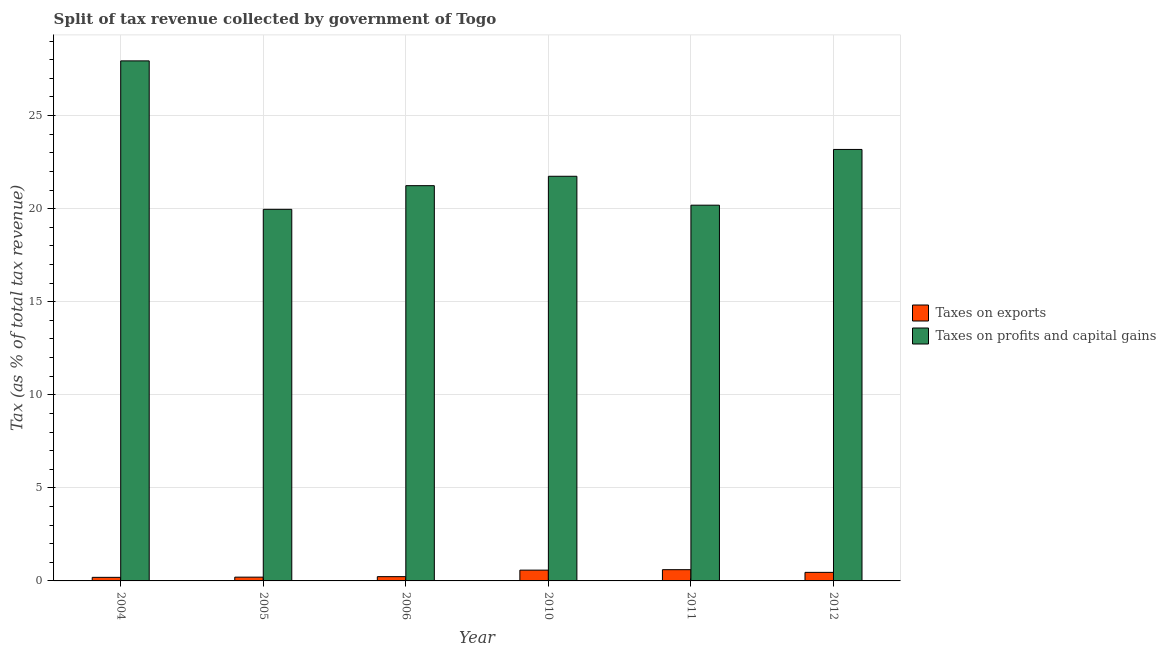Are the number of bars per tick equal to the number of legend labels?
Your response must be concise. Yes. Are the number of bars on each tick of the X-axis equal?
Keep it short and to the point. Yes. How many bars are there on the 2nd tick from the left?
Provide a short and direct response. 2. How many bars are there on the 6th tick from the right?
Offer a very short reply. 2. What is the label of the 5th group of bars from the left?
Your answer should be very brief. 2011. What is the percentage of revenue obtained from taxes on exports in 2012?
Your answer should be very brief. 0.46. Across all years, what is the maximum percentage of revenue obtained from taxes on exports?
Provide a succinct answer. 0.6. Across all years, what is the minimum percentage of revenue obtained from taxes on exports?
Your response must be concise. 0.19. In which year was the percentage of revenue obtained from taxes on exports maximum?
Keep it short and to the point. 2011. In which year was the percentage of revenue obtained from taxes on exports minimum?
Make the answer very short. 2004. What is the total percentage of revenue obtained from taxes on profits and capital gains in the graph?
Your response must be concise. 134.25. What is the difference between the percentage of revenue obtained from taxes on profits and capital gains in 2006 and that in 2011?
Keep it short and to the point. 1.05. What is the difference between the percentage of revenue obtained from taxes on profits and capital gains in 2011 and the percentage of revenue obtained from taxes on exports in 2004?
Keep it short and to the point. -7.75. What is the average percentage of revenue obtained from taxes on profits and capital gains per year?
Ensure brevity in your answer.  22.37. In the year 2011, what is the difference between the percentage of revenue obtained from taxes on exports and percentage of revenue obtained from taxes on profits and capital gains?
Your answer should be very brief. 0. In how many years, is the percentage of revenue obtained from taxes on profits and capital gains greater than 14 %?
Offer a very short reply. 6. What is the ratio of the percentage of revenue obtained from taxes on profits and capital gains in 2004 to that in 2005?
Your answer should be compact. 1.4. Is the percentage of revenue obtained from taxes on exports in 2005 less than that in 2012?
Make the answer very short. Yes. Is the difference between the percentage of revenue obtained from taxes on profits and capital gains in 2004 and 2012 greater than the difference between the percentage of revenue obtained from taxes on exports in 2004 and 2012?
Keep it short and to the point. No. What is the difference between the highest and the second highest percentage of revenue obtained from taxes on exports?
Ensure brevity in your answer.  0.02. What is the difference between the highest and the lowest percentage of revenue obtained from taxes on profits and capital gains?
Provide a short and direct response. 7.98. Is the sum of the percentage of revenue obtained from taxes on exports in 2005 and 2012 greater than the maximum percentage of revenue obtained from taxes on profits and capital gains across all years?
Offer a terse response. Yes. What does the 2nd bar from the left in 2011 represents?
Provide a short and direct response. Taxes on profits and capital gains. What does the 1st bar from the right in 2010 represents?
Make the answer very short. Taxes on profits and capital gains. How many bars are there?
Provide a short and direct response. 12. Are all the bars in the graph horizontal?
Make the answer very short. No. What is the difference between two consecutive major ticks on the Y-axis?
Your answer should be compact. 5. Does the graph contain any zero values?
Your answer should be compact. No. Where does the legend appear in the graph?
Your response must be concise. Center right. What is the title of the graph?
Give a very brief answer. Split of tax revenue collected by government of Togo. What is the label or title of the Y-axis?
Make the answer very short. Tax (as % of total tax revenue). What is the Tax (as % of total tax revenue) of Taxes on exports in 2004?
Offer a terse response. 0.19. What is the Tax (as % of total tax revenue) in Taxes on profits and capital gains in 2004?
Make the answer very short. 27.94. What is the Tax (as % of total tax revenue) of Taxes on exports in 2005?
Keep it short and to the point. 0.2. What is the Tax (as % of total tax revenue) in Taxes on profits and capital gains in 2005?
Keep it short and to the point. 19.96. What is the Tax (as % of total tax revenue) of Taxes on exports in 2006?
Your answer should be compact. 0.23. What is the Tax (as % of total tax revenue) in Taxes on profits and capital gains in 2006?
Provide a short and direct response. 21.24. What is the Tax (as % of total tax revenue) of Taxes on exports in 2010?
Ensure brevity in your answer.  0.58. What is the Tax (as % of total tax revenue) of Taxes on profits and capital gains in 2010?
Your answer should be compact. 21.74. What is the Tax (as % of total tax revenue) of Taxes on exports in 2011?
Your answer should be compact. 0.6. What is the Tax (as % of total tax revenue) in Taxes on profits and capital gains in 2011?
Offer a terse response. 20.19. What is the Tax (as % of total tax revenue) in Taxes on exports in 2012?
Offer a terse response. 0.46. What is the Tax (as % of total tax revenue) of Taxes on profits and capital gains in 2012?
Your response must be concise. 23.18. Across all years, what is the maximum Tax (as % of total tax revenue) in Taxes on exports?
Your answer should be compact. 0.6. Across all years, what is the maximum Tax (as % of total tax revenue) of Taxes on profits and capital gains?
Make the answer very short. 27.94. Across all years, what is the minimum Tax (as % of total tax revenue) in Taxes on exports?
Offer a terse response. 0.19. Across all years, what is the minimum Tax (as % of total tax revenue) of Taxes on profits and capital gains?
Ensure brevity in your answer.  19.96. What is the total Tax (as % of total tax revenue) of Taxes on exports in the graph?
Give a very brief answer. 2.27. What is the total Tax (as % of total tax revenue) of Taxes on profits and capital gains in the graph?
Provide a short and direct response. 134.25. What is the difference between the Tax (as % of total tax revenue) of Taxes on exports in 2004 and that in 2005?
Ensure brevity in your answer.  -0.01. What is the difference between the Tax (as % of total tax revenue) in Taxes on profits and capital gains in 2004 and that in 2005?
Give a very brief answer. 7.98. What is the difference between the Tax (as % of total tax revenue) of Taxes on exports in 2004 and that in 2006?
Your answer should be compact. -0.04. What is the difference between the Tax (as % of total tax revenue) in Taxes on profits and capital gains in 2004 and that in 2006?
Provide a short and direct response. 6.7. What is the difference between the Tax (as % of total tax revenue) in Taxes on exports in 2004 and that in 2010?
Give a very brief answer. -0.39. What is the difference between the Tax (as % of total tax revenue) of Taxes on profits and capital gains in 2004 and that in 2010?
Provide a succinct answer. 6.2. What is the difference between the Tax (as % of total tax revenue) of Taxes on exports in 2004 and that in 2011?
Keep it short and to the point. -0.41. What is the difference between the Tax (as % of total tax revenue) of Taxes on profits and capital gains in 2004 and that in 2011?
Your response must be concise. 7.75. What is the difference between the Tax (as % of total tax revenue) of Taxes on exports in 2004 and that in 2012?
Ensure brevity in your answer.  -0.27. What is the difference between the Tax (as % of total tax revenue) in Taxes on profits and capital gains in 2004 and that in 2012?
Make the answer very short. 4.76. What is the difference between the Tax (as % of total tax revenue) of Taxes on exports in 2005 and that in 2006?
Your response must be concise. -0.03. What is the difference between the Tax (as % of total tax revenue) in Taxes on profits and capital gains in 2005 and that in 2006?
Offer a terse response. -1.27. What is the difference between the Tax (as % of total tax revenue) of Taxes on exports in 2005 and that in 2010?
Offer a very short reply. -0.38. What is the difference between the Tax (as % of total tax revenue) in Taxes on profits and capital gains in 2005 and that in 2010?
Provide a succinct answer. -1.78. What is the difference between the Tax (as % of total tax revenue) of Taxes on exports in 2005 and that in 2011?
Your answer should be very brief. -0.4. What is the difference between the Tax (as % of total tax revenue) of Taxes on profits and capital gains in 2005 and that in 2011?
Make the answer very short. -0.22. What is the difference between the Tax (as % of total tax revenue) in Taxes on exports in 2005 and that in 2012?
Ensure brevity in your answer.  -0.26. What is the difference between the Tax (as % of total tax revenue) in Taxes on profits and capital gains in 2005 and that in 2012?
Your answer should be compact. -3.22. What is the difference between the Tax (as % of total tax revenue) in Taxes on exports in 2006 and that in 2010?
Your answer should be very brief. -0.35. What is the difference between the Tax (as % of total tax revenue) in Taxes on profits and capital gains in 2006 and that in 2010?
Your answer should be very brief. -0.5. What is the difference between the Tax (as % of total tax revenue) of Taxes on exports in 2006 and that in 2011?
Ensure brevity in your answer.  -0.37. What is the difference between the Tax (as % of total tax revenue) of Taxes on profits and capital gains in 2006 and that in 2011?
Give a very brief answer. 1.05. What is the difference between the Tax (as % of total tax revenue) in Taxes on exports in 2006 and that in 2012?
Your answer should be very brief. -0.23. What is the difference between the Tax (as % of total tax revenue) of Taxes on profits and capital gains in 2006 and that in 2012?
Make the answer very short. -1.95. What is the difference between the Tax (as % of total tax revenue) of Taxes on exports in 2010 and that in 2011?
Your answer should be compact. -0.02. What is the difference between the Tax (as % of total tax revenue) of Taxes on profits and capital gains in 2010 and that in 2011?
Offer a terse response. 1.55. What is the difference between the Tax (as % of total tax revenue) in Taxes on exports in 2010 and that in 2012?
Give a very brief answer. 0.12. What is the difference between the Tax (as % of total tax revenue) in Taxes on profits and capital gains in 2010 and that in 2012?
Your response must be concise. -1.44. What is the difference between the Tax (as % of total tax revenue) of Taxes on exports in 2011 and that in 2012?
Make the answer very short. 0.14. What is the difference between the Tax (as % of total tax revenue) of Taxes on profits and capital gains in 2011 and that in 2012?
Provide a short and direct response. -2.99. What is the difference between the Tax (as % of total tax revenue) of Taxes on exports in 2004 and the Tax (as % of total tax revenue) of Taxes on profits and capital gains in 2005?
Your response must be concise. -19.77. What is the difference between the Tax (as % of total tax revenue) in Taxes on exports in 2004 and the Tax (as % of total tax revenue) in Taxes on profits and capital gains in 2006?
Keep it short and to the point. -21.04. What is the difference between the Tax (as % of total tax revenue) in Taxes on exports in 2004 and the Tax (as % of total tax revenue) in Taxes on profits and capital gains in 2010?
Your answer should be very brief. -21.55. What is the difference between the Tax (as % of total tax revenue) in Taxes on exports in 2004 and the Tax (as % of total tax revenue) in Taxes on profits and capital gains in 2011?
Make the answer very short. -20. What is the difference between the Tax (as % of total tax revenue) of Taxes on exports in 2004 and the Tax (as % of total tax revenue) of Taxes on profits and capital gains in 2012?
Your answer should be very brief. -22.99. What is the difference between the Tax (as % of total tax revenue) in Taxes on exports in 2005 and the Tax (as % of total tax revenue) in Taxes on profits and capital gains in 2006?
Offer a very short reply. -21.03. What is the difference between the Tax (as % of total tax revenue) of Taxes on exports in 2005 and the Tax (as % of total tax revenue) of Taxes on profits and capital gains in 2010?
Your answer should be very brief. -21.54. What is the difference between the Tax (as % of total tax revenue) in Taxes on exports in 2005 and the Tax (as % of total tax revenue) in Taxes on profits and capital gains in 2011?
Offer a very short reply. -19.98. What is the difference between the Tax (as % of total tax revenue) of Taxes on exports in 2005 and the Tax (as % of total tax revenue) of Taxes on profits and capital gains in 2012?
Keep it short and to the point. -22.98. What is the difference between the Tax (as % of total tax revenue) of Taxes on exports in 2006 and the Tax (as % of total tax revenue) of Taxes on profits and capital gains in 2010?
Provide a succinct answer. -21.51. What is the difference between the Tax (as % of total tax revenue) of Taxes on exports in 2006 and the Tax (as % of total tax revenue) of Taxes on profits and capital gains in 2011?
Provide a short and direct response. -19.96. What is the difference between the Tax (as % of total tax revenue) of Taxes on exports in 2006 and the Tax (as % of total tax revenue) of Taxes on profits and capital gains in 2012?
Provide a succinct answer. -22.95. What is the difference between the Tax (as % of total tax revenue) in Taxes on exports in 2010 and the Tax (as % of total tax revenue) in Taxes on profits and capital gains in 2011?
Offer a very short reply. -19.61. What is the difference between the Tax (as % of total tax revenue) of Taxes on exports in 2010 and the Tax (as % of total tax revenue) of Taxes on profits and capital gains in 2012?
Ensure brevity in your answer.  -22.6. What is the difference between the Tax (as % of total tax revenue) of Taxes on exports in 2011 and the Tax (as % of total tax revenue) of Taxes on profits and capital gains in 2012?
Your answer should be compact. -22.58. What is the average Tax (as % of total tax revenue) in Taxes on exports per year?
Keep it short and to the point. 0.38. What is the average Tax (as % of total tax revenue) of Taxes on profits and capital gains per year?
Give a very brief answer. 22.37. In the year 2004, what is the difference between the Tax (as % of total tax revenue) of Taxes on exports and Tax (as % of total tax revenue) of Taxes on profits and capital gains?
Offer a very short reply. -27.75. In the year 2005, what is the difference between the Tax (as % of total tax revenue) of Taxes on exports and Tax (as % of total tax revenue) of Taxes on profits and capital gains?
Offer a terse response. -19.76. In the year 2006, what is the difference between the Tax (as % of total tax revenue) in Taxes on exports and Tax (as % of total tax revenue) in Taxes on profits and capital gains?
Give a very brief answer. -21.01. In the year 2010, what is the difference between the Tax (as % of total tax revenue) in Taxes on exports and Tax (as % of total tax revenue) in Taxes on profits and capital gains?
Give a very brief answer. -21.16. In the year 2011, what is the difference between the Tax (as % of total tax revenue) of Taxes on exports and Tax (as % of total tax revenue) of Taxes on profits and capital gains?
Your answer should be very brief. -19.58. In the year 2012, what is the difference between the Tax (as % of total tax revenue) in Taxes on exports and Tax (as % of total tax revenue) in Taxes on profits and capital gains?
Your response must be concise. -22.72. What is the ratio of the Tax (as % of total tax revenue) in Taxes on exports in 2004 to that in 2005?
Provide a short and direct response. 0.95. What is the ratio of the Tax (as % of total tax revenue) of Taxes on profits and capital gains in 2004 to that in 2005?
Ensure brevity in your answer.  1.4. What is the ratio of the Tax (as % of total tax revenue) of Taxes on exports in 2004 to that in 2006?
Keep it short and to the point. 0.83. What is the ratio of the Tax (as % of total tax revenue) of Taxes on profits and capital gains in 2004 to that in 2006?
Your answer should be compact. 1.32. What is the ratio of the Tax (as % of total tax revenue) of Taxes on exports in 2004 to that in 2010?
Offer a very short reply. 0.33. What is the ratio of the Tax (as % of total tax revenue) of Taxes on profits and capital gains in 2004 to that in 2010?
Keep it short and to the point. 1.29. What is the ratio of the Tax (as % of total tax revenue) of Taxes on exports in 2004 to that in 2011?
Offer a terse response. 0.32. What is the ratio of the Tax (as % of total tax revenue) of Taxes on profits and capital gains in 2004 to that in 2011?
Offer a very short reply. 1.38. What is the ratio of the Tax (as % of total tax revenue) of Taxes on exports in 2004 to that in 2012?
Your response must be concise. 0.42. What is the ratio of the Tax (as % of total tax revenue) of Taxes on profits and capital gains in 2004 to that in 2012?
Offer a very short reply. 1.21. What is the ratio of the Tax (as % of total tax revenue) in Taxes on exports in 2005 to that in 2006?
Provide a short and direct response. 0.88. What is the ratio of the Tax (as % of total tax revenue) in Taxes on profits and capital gains in 2005 to that in 2006?
Your answer should be very brief. 0.94. What is the ratio of the Tax (as % of total tax revenue) in Taxes on exports in 2005 to that in 2010?
Offer a terse response. 0.35. What is the ratio of the Tax (as % of total tax revenue) in Taxes on profits and capital gains in 2005 to that in 2010?
Your response must be concise. 0.92. What is the ratio of the Tax (as % of total tax revenue) of Taxes on exports in 2005 to that in 2011?
Your answer should be very brief. 0.34. What is the ratio of the Tax (as % of total tax revenue) of Taxes on profits and capital gains in 2005 to that in 2011?
Give a very brief answer. 0.99. What is the ratio of the Tax (as % of total tax revenue) in Taxes on exports in 2005 to that in 2012?
Your answer should be very brief. 0.44. What is the ratio of the Tax (as % of total tax revenue) of Taxes on profits and capital gains in 2005 to that in 2012?
Offer a very short reply. 0.86. What is the ratio of the Tax (as % of total tax revenue) in Taxes on exports in 2006 to that in 2010?
Offer a terse response. 0.4. What is the ratio of the Tax (as % of total tax revenue) in Taxes on profits and capital gains in 2006 to that in 2010?
Provide a succinct answer. 0.98. What is the ratio of the Tax (as % of total tax revenue) of Taxes on exports in 2006 to that in 2011?
Offer a very short reply. 0.38. What is the ratio of the Tax (as % of total tax revenue) in Taxes on profits and capital gains in 2006 to that in 2011?
Keep it short and to the point. 1.05. What is the ratio of the Tax (as % of total tax revenue) in Taxes on exports in 2006 to that in 2012?
Provide a succinct answer. 0.5. What is the ratio of the Tax (as % of total tax revenue) of Taxes on profits and capital gains in 2006 to that in 2012?
Provide a succinct answer. 0.92. What is the ratio of the Tax (as % of total tax revenue) in Taxes on exports in 2010 to that in 2011?
Offer a very short reply. 0.96. What is the ratio of the Tax (as % of total tax revenue) in Taxes on profits and capital gains in 2010 to that in 2011?
Offer a terse response. 1.08. What is the ratio of the Tax (as % of total tax revenue) in Taxes on exports in 2010 to that in 2012?
Your response must be concise. 1.26. What is the ratio of the Tax (as % of total tax revenue) of Taxes on profits and capital gains in 2010 to that in 2012?
Offer a terse response. 0.94. What is the ratio of the Tax (as % of total tax revenue) of Taxes on exports in 2011 to that in 2012?
Give a very brief answer. 1.31. What is the ratio of the Tax (as % of total tax revenue) of Taxes on profits and capital gains in 2011 to that in 2012?
Provide a short and direct response. 0.87. What is the difference between the highest and the second highest Tax (as % of total tax revenue) in Taxes on exports?
Provide a succinct answer. 0.02. What is the difference between the highest and the second highest Tax (as % of total tax revenue) in Taxes on profits and capital gains?
Provide a succinct answer. 4.76. What is the difference between the highest and the lowest Tax (as % of total tax revenue) in Taxes on exports?
Offer a very short reply. 0.41. What is the difference between the highest and the lowest Tax (as % of total tax revenue) in Taxes on profits and capital gains?
Ensure brevity in your answer.  7.98. 